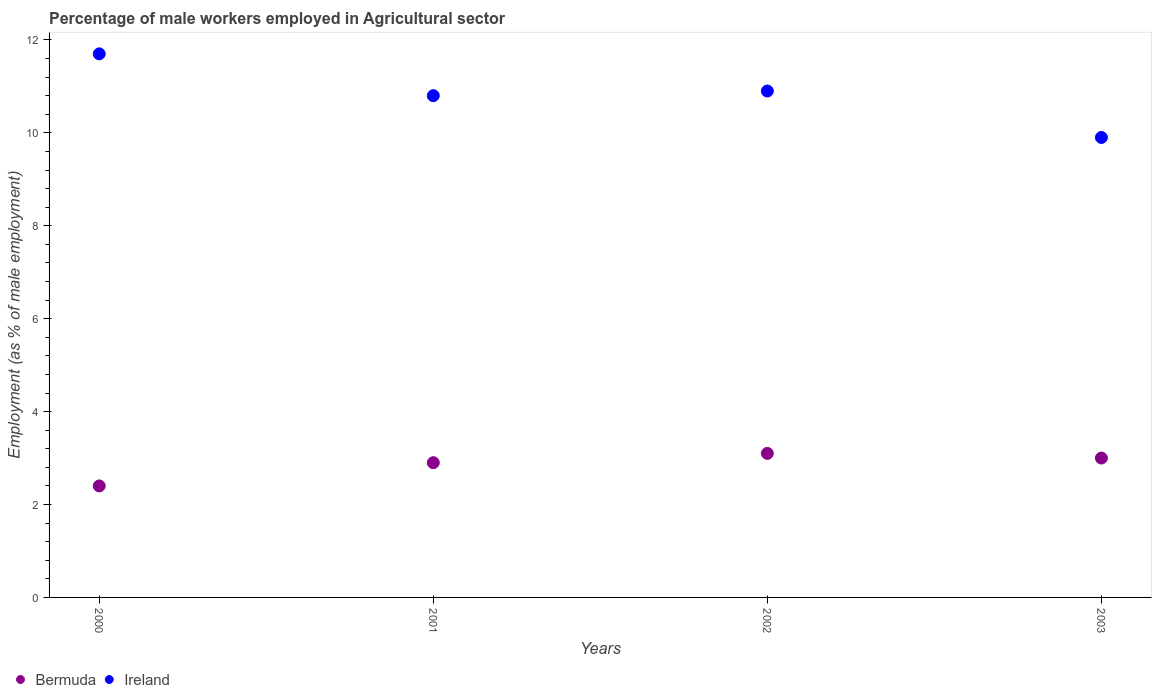What is the percentage of male workers employed in Agricultural sector in Ireland in 2003?
Give a very brief answer. 9.9. Across all years, what is the maximum percentage of male workers employed in Agricultural sector in Bermuda?
Your answer should be compact. 3.1. Across all years, what is the minimum percentage of male workers employed in Agricultural sector in Bermuda?
Provide a short and direct response. 2.4. In which year was the percentage of male workers employed in Agricultural sector in Ireland minimum?
Your answer should be very brief. 2003. What is the total percentage of male workers employed in Agricultural sector in Ireland in the graph?
Keep it short and to the point. 43.3. What is the difference between the percentage of male workers employed in Agricultural sector in Bermuda in 2000 and that in 2002?
Provide a short and direct response. -0.7. What is the difference between the percentage of male workers employed in Agricultural sector in Bermuda in 2000 and the percentage of male workers employed in Agricultural sector in Ireland in 2001?
Keep it short and to the point. -8.4. What is the average percentage of male workers employed in Agricultural sector in Bermuda per year?
Offer a very short reply. 2.85. In the year 2000, what is the difference between the percentage of male workers employed in Agricultural sector in Bermuda and percentage of male workers employed in Agricultural sector in Ireland?
Your response must be concise. -9.3. What is the ratio of the percentage of male workers employed in Agricultural sector in Ireland in 2000 to that in 2002?
Give a very brief answer. 1.07. What is the difference between the highest and the second highest percentage of male workers employed in Agricultural sector in Ireland?
Your answer should be compact. 0.8. What is the difference between the highest and the lowest percentage of male workers employed in Agricultural sector in Bermuda?
Provide a succinct answer. 0.7. Is the sum of the percentage of male workers employed in Agricultural sector in Ireland in 2001 and 2003 greater than the maximum percentage of male workers employed in Agricultural sector in Bermuda across all years?
Your answer should be compact. Yes. Does the percentage of male workers employed in Agricultural sector in Bermuda monotonically increase over the years?
Ensure brevity in your answer.  No. Is the percentage of male workers employed in Agricultural sector in Ireland strictly greater than the percentage of male workers employed in Agricultural sector in Bermuda over the years?
Make the answer very short. Yes. How many dotlines are there?
Your answer should be compact. 2. How many years are there in the graph?
Your response must be concise. 4. What is the difference between two consecutive major ticks on the Y-axis?
Provide a short and direct response. 2. What is the title of the graph?
Keep it short and to the point. Percentage of male workers employed in Agricultural sector. What is the label or title of the X-axis?
Ensure brevity in your answer.  Years. What is the label or title of the Y-axis?
Provide a succinct answer. Employment (as % of male employment). What is the Employment (as % of male employment) in Bermuda in 2000?
Make the answer very short. 2.4. What is the Employment (as % of male employment) in Ireland in 2000?
Make the answer very short. 11.7. What is the Employment (as % of male employment) of Bermuda in 2001?
Make the answer very short. 2.9. What is the Employment (as % of male employment) of Ireland in 2001?
Make the answer very short. 10.8. What is the Employment (as % of male employment) in Bermuda in 2002?
Give a very brief answer. 3.1. What is the Employment (as % of male employment) in Ireland in 2002?
Give a very brief answer. 10.9. What is the Employment (as % of male employment) in Bermuda in 2003?
Your response must be concise. 3. What is the Employment (as % of male employment) in Ireland in 2003?
Make the answer very short. 9.9. Across all years, what is the maximum Employment (as % of male employment) of Bermuda?
Offer a terse response. 3.1. Across all years, what is the maximum Employment (as % of male employment) in Ireland?
Offer a very short reply. 11.7. Across all years, what is the minimum Employment (as % of male employment) in Bermuda?
Your answer should be very brief. 2.4. Across all years, what is the minimum Employment (as % of male employment) of Ireland?
Keep it short and to the point. 9.9. What is the total Employment (as % of male employment) in Bermuda in the graph?
Ensure brevity in your answer.  11.4. What is the total Employment (as % of male employment) of Ireland in the graph?
Make the answer very short. 43.3. What is the difference between the Employment (as % of male employment) in Bermuda in 2000 and that in 2001?
Offer a terse response. -0.5. What is the difference between the Employment (as % of male employment) in Ireland in 2000 and that in 2001?
Give a very brief answer. 0.9. What is the difference between the Employment (as % of male employment) in Bermuda in 2000 and that in 2002?
Your response must be concise. -0.7. What is the difference between the Employment (as % of male employment) of Bermuda in 2000 and that in 2003?
Your answer should be very brief. -0.6. What is the difference between the Employment (as % of male employment) in Ireland in 2000 and that in 2003?
Provide a short and direct response. 1.8. What is the difference between the Employment (as % of male employment) of Bermuda in 2001 and that in 2002?
Keep it short and to the point. -0.2. What is the difference between the Employment (as % of male employment) of Ireland in 2001 and that in 2003?
Ensure brevity in your answer.  0.9. What is the difference between the Employment (as % of male employment) of Ireland in 2002 and that in 2003?
Keep it short and to the point. 1. What is the difference between the Employment (as % of male employment) of Bermuda in 2001 and the Employment (as % of male employment) of Ireland in 2002?
Your response must be concise. -8. What is the difference between the Employment (as % of male employment) of Bermuda in 2001 and the Employment (as % of male employment) of Ireland in 2003?
Keep it short and to the point. -7. What is the difference between the Employment (as % of male employment) of Bermuda in 2002 and the Employment (as % of male employment) of Ireland in 2003?
Offer a very short reply. -6.8. What is the average Employment (as % of male employment) of Bermuda per year?
Keep it short and to the point. 2.85. What is the average Employment (as % of male employment) of Ireland per year?
Your answer should be very brief. 10.82. In the year 2001, what is the difference between the Employment (as % of male employment) of Bermuda and Employment (as % of male employment) of Ireland?
Your response must be concise. -7.9. In the year 2003, what is the difference between the Employment (as % of male employment) in Bermuda and Employment (as % of male employment) in Ireland?
Give a very brief answer. -6.9. What is the ratio of the Employment (as % of male employment) of Bermuda in 2000 to that in 2001?
Offer a terse response. 0.83. What is the ratio of the Employment (as % of male employment) in Ireland in 2000 to that in 2001?
Your answer should be very brief. 1.08. What is the ratio of the Employment (as % of male employment) of Bermuda in 2000 to that in 2002?
Give a very brief answer. 0.77. What is the ratio of the Employment (as % of male employment) in Ireland in 2000 to that in 2002?
Offer a very short reply. 1.07. What is the ratio of the Employment (as % of male employment) in Ireland in 2000 to that in 2003?
Offer a very short reply. 1.18. What is the ratio of the Employment (as % of male employment) of Bermuda in 2001 to that in 2002?
Provide a short and direct response. 0.94. What is the ratio of the Employment (as % of male employment) in Ireland in 2001 to that in 2002?
Give a very brief answer. 0.99. What is the ratio of the Employment (as % of male employment) in Bermuda in 2001 to that in 2003?
Keep it short and to the point. 0.97. What is the ratio of the Employment (as % of male employment) in Ireland in 2002 to that in 2003?
Give a very brief answer. 1.1. What is the difference between the highest and the second highest Employment (as % of male employment) in Bermuda?
Provide a short and direct response. 0.1. What is the difference between the highest and the lowest Employment (as % of male employment) of Bermuda?
Your answer should be compact. 0.7. What is the difference between the highest and the lowest Employment (as % of male employment) in Ireland?
Your answer should be compact. 1.8. 